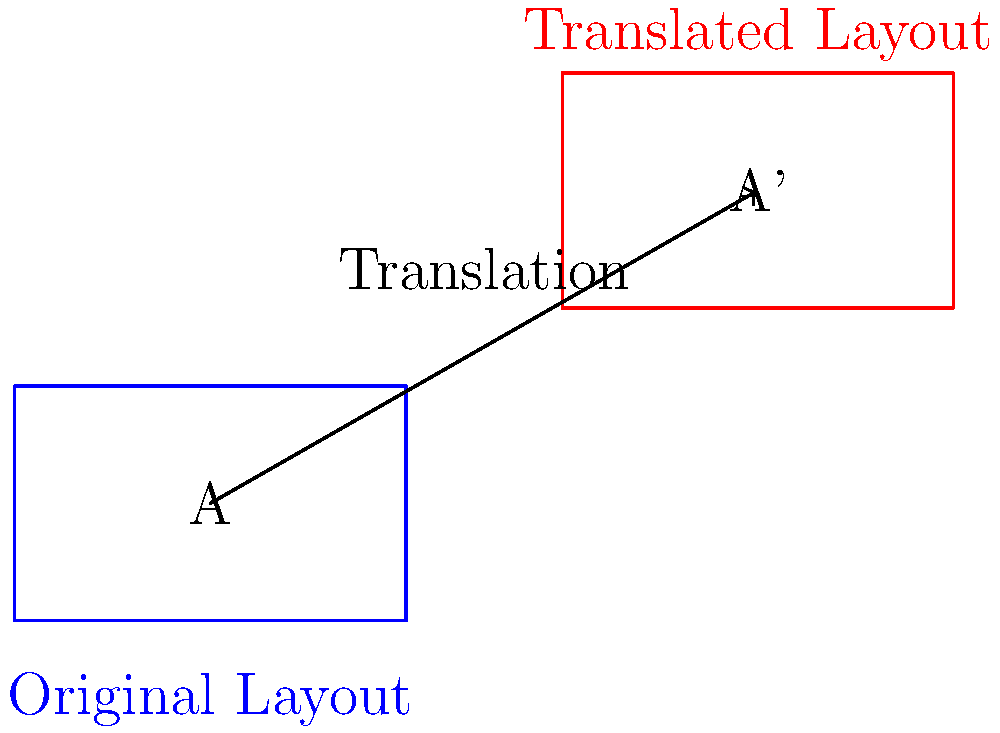In an effort to optimize boarding procedures, you need to relocate a passenger queue layout in the airport terminal. The original rectangular queue area (labeled A) measures 50 feet by 30 feet. If you translate this queue layout 70 feet in the x-direction and 40 feet in the y-direction to the new position (labeled A'), what is the total distance the queue has been moved? To solve this problem, we need to follow these steps:

1. Identify the translation vector:
   The queue is moved 70 feet in the x-direction and 40 feet in the y-direction.
   This gives us a translation vector of (70, 40).

2. Calculate the distance using the Pythagorean theorem:
   Distance = $\sqrt{(x \text{ translation})^2 + (y \text{ translation})^2}$
   
   $$ \text{Distance} = \sqrt{70^2 + 40^2} $$

3. Simplify:
   $$ \text{Distance} = \sqrt{4900 + 1600} = \sqrt{6500} $$

4. Calculate the final result:
   $$ \text{Distance} = \sqrt{6500} \approx 80.62 \text{ feet} $$

Therefore, the total distance the queue has been moved is approximately 80.62 feet.
Answer: 80.62 feet 